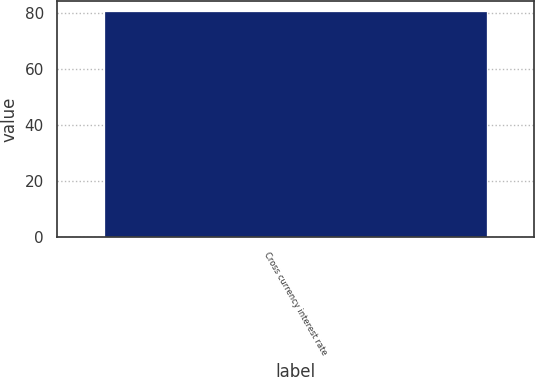Convert chart. <chart><loc_0><loc_0><loc_500><loc_500><bar_chart><fcel>Cross currency interest rate<nl><fcel>80.2<nl></chart> 